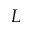Convert formula to latex. <formula><loc_0><loc_0><loc_500><loc_500>L</formula> 